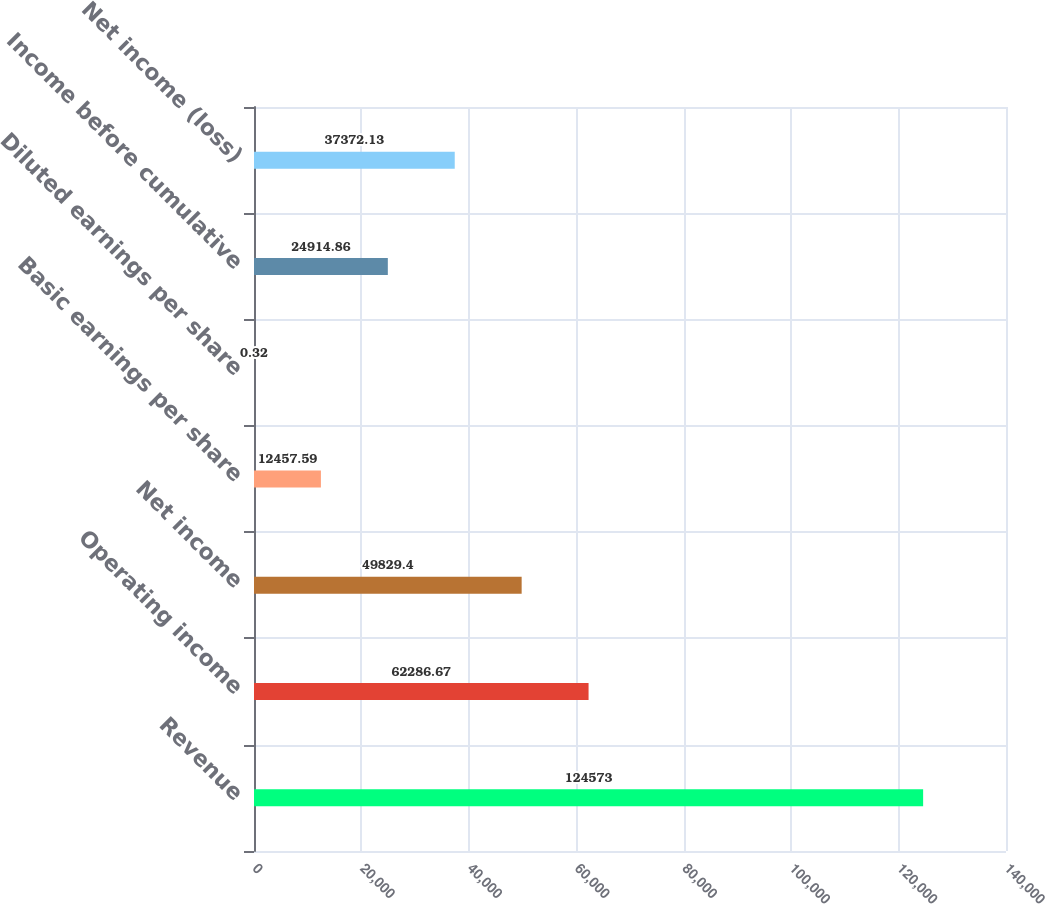<chart> <loc_0><loc_0><loc_500><loc_500><bar_chart><fcel>Revenue<fcel>Operating income<fcel>Net income<fcel>Basic earnings per share<fcel>Diluted earnings per share<fcel>Income before cumulative<fcel>Net income (loss)<nl><fcel>124573<fcel>62286.7<fcel>49829.4<fcel>12457.6<fcel>0.32<fcel>24914.9<fcel>37372.1<nl></chart> 